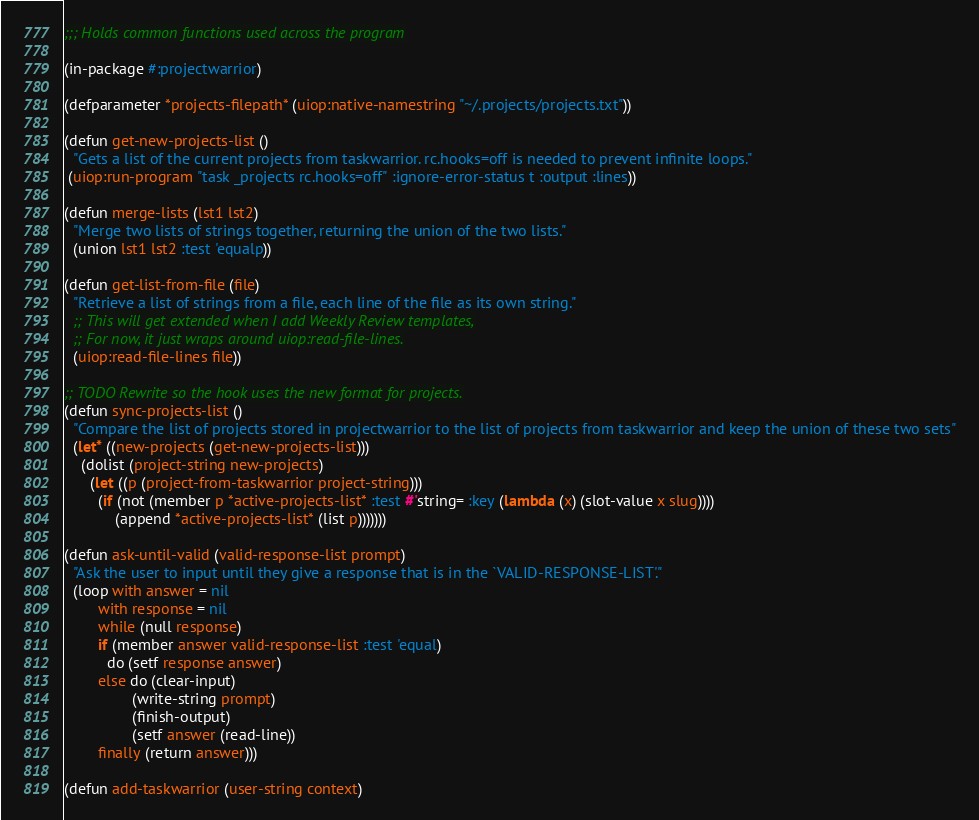<code> <loc_0><loc_0><loc_500><loc_500><_Lisp_>;;; Holds common functions used across the program

(in-package #:projectwarrior)

(defparameter *projects-filepath* (uiop:native-namestring "~/.projects/projects.txt"))

(defun get-new-projects-list ()
  "Gets a list of the current projects from taskwarrior. rc.hooks=off is needed to prevent infinite loops."
 (uiop:run-program "task _projects rc.hooks=off" :ignore-error-status t :output :lines))

(defun merge-lists (lst1 lst2)
  "Merge two lists of strings together, returning the union of the two lists."
  (union lst1 lst2 :test 'equalp))

(defun get-list-from-file (file)
  "Retrieve a list of strings from a file, each line of the file as its own string."
  ;; This will get extended when I add Weekly Review templates,
  ;; For now, it just wraps around uiop:read-file-lines.
  (uiop:read-file-lines file))

;; TODO Rewrite so the hook uses the new format for projects.
(defun sync-projects-list ()
  "Compare the list of projects stored in projectwarrior to the list of projects from taskwarrior and keep the union of these two sets"
  (let* ((new-projects (get-new-projects-list)))
    (dolist (project-string new-projects)
      (let ((p (project-from-taskwarrior project-string)))
        (if (not (member p *active-projects-list* :test #'string= :key (lambda (x) (slot-value x slug))))
            (append *active-projects-list* (list p)))))))

(defun ask-until-valid (valid-response-list prompt)
  "Ask the user to input until they give a response that is in the `VALID-RESPONSE-LIST'."
  (loop with answer = nil
        with response = nil
        while (null response)
        if (member answer valid-response-list :test 'equal)
          do (setf response answer)
        else do (clear-input)
                (write-string prompt)
                (finish-output)
                (setf answer (read-line))
        finally (return answer)))

(defun add-taskwarrior (user-string context)</code> 